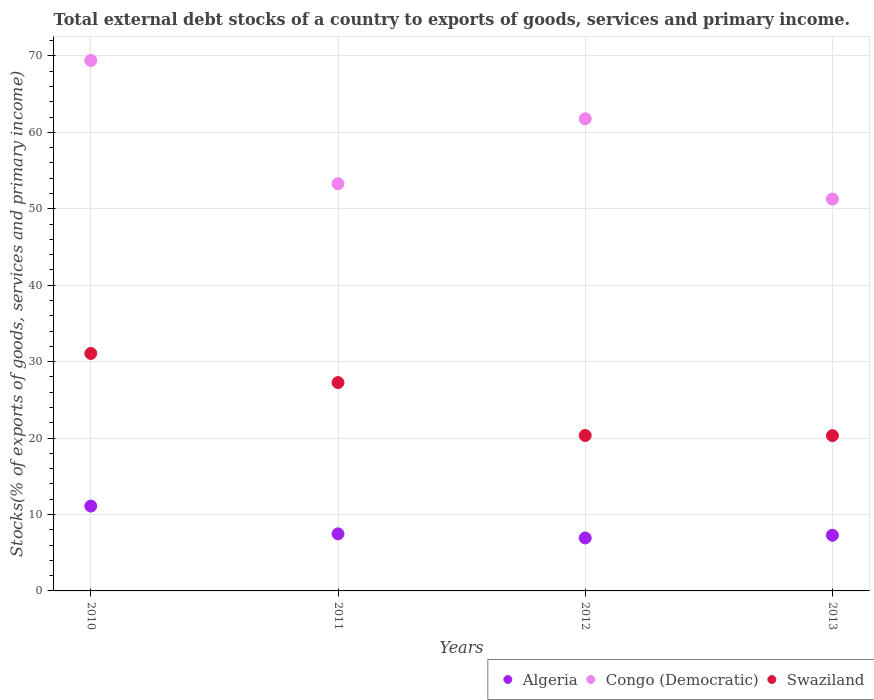How many different coloured dotlines are there?
Offer a very short reply. 3. What is the total debt stocks in Algeria in 2011?
Offer a terse response. 7.47. Across all years, what is the maximum total debt stocks in Swaziland?
Your answer should be very brief. 31.08. Across all years, what is the minimum total debt stocks in Algeria?
Your response must be concise. 6.93. In which year was the total debt stocks in Congo (Democratic) maximum?
Your answer should be very brief. 2010. In which year was the total debt stocks in Algeria minimum?
Give a very brief answer. 2012. What is the total total debt stocks in Algeria in the graph?
Give a very brief answer. 32.79. What is the difference between the total debt stocks in Congo (Democratic) in 2010 and that in 2012?
Your answer should be very brief. 7.63. What is the difference between the total debt stocks in Congo (Democratic) in 2011 and the total debt stocks in Algeria in 2013?
Your answer should be compact. 46. What is the average total debt stocks in Algeria per year?
Your answer should be very brief. 8.2. In the year 2013, what is the difference between the total debt stocks in Congo (Democratic) and total debt stocks in Swaziland?
Provide a succinct answer. 30.95. In how many years, is the total debt stocks in Congo (Democratic) greater than 62 %?
Keep it short and to the point. 1. What is the ratio of the total debt stocks in Swaziland in 2010 to that in 2011?
Give a very brief answer. 1.14. Is the total debt stocks in Swaziland in 2010 less than that in 2012?
Offer a very short reply. No. Is the difference between the total debt stocks in Congo (Democratic) in 2011 and 2012 greater than the difference between the total debt stocks in Swaziland in 2011 and 2012?
Offer a very short reply. No. What is the difference between the highest and the second highest total debt stocks in Algeria?
Your answer should be very brief. 3.64. What is the difference between the highest and the lowest total debt stocks in Congo (Democratic)?
Your answer should be very brief. 18.15. Is it the case that in every year, the sum of the total debt stocks in Swaziland and total debt stocks in Algeria  is greater than the total debt stocks in Congo (Democratic)?
Keep it short and to the point. No. Does the total debt stocks in Algeria monotonically increase over the years?
Your answer should be very brief. No. Is the total debt stocks in Algeria strictly greater than the total debt stocks in Swaziland over the years?
Offer a terse response. No. Is the total debt stocks in Congo (Democratic) strictly less than the total debt stocks in Swaziland over the years?
Offer a very short reply. No. How many dotlines are there?
Ensure brevity in your answer.  3. What is the difference between two consecutive major ticks on the Y-axis?
Provide a succinct answer. 10. Are the values on the major ticks of Y-axis written in scientific E-notation?
Your answer should be very brief. No. Does the graph contain any zero values?
Make the answer very short. No. Where does the legend appear in the graph?
Provide a succinct answer. Bottom right. What is the title of the graph?
Offer a terse response. Total external debt stocks of a country to exports of goods, services and primary income. What is the label or title of the X-axis?
Ensure brevity in your answer.  Years. What is the label or title of the Y-axis?
Keep it short and to the point. Stocks(% of exports of goods, services and primary income). What is the Stocks(% of exports of goods, services and primary income) of Algeria in 2010?
Ensure brevity in your answer.  11.1. What is the Stocks(% of exports of goods, services and primary income) in Congo (Democratic) in 2010?
Your answer should be very brief. 69.42. What is the Stocks(% of exports of goods, services and primary income) of Swaziland in 2010?
Provide a short and direct response. 31.08. What is the Stocks(% of exports of goods, services and primary income) of Algeria in 2011?
Ensure brevity in your answer.  7.47. What is the Stocks(% of exports of goods, services and primary income) of Congo (Democratic) in 2011?
Offer a terse response. 53.28. What is the Stocks(% of exports of goods, services and primary income) in Swaziland in 2011?
Give a very brief answer. 27.26. What is the Stocks(% of exports of goods, services and primary income) in Algeria in 2012?
Provide a succinct answer. 6.93. What is the Stocks(% of exports of goods, services and primary income) of Congo (Democratic) in 2012?
Provide a short and direct response. 61.78. What is the Stocks(% of exports of goods, services and primary income) in Swaziland in 2012?
Provide a succinct answer. 20.34. What is the Stocks(% of exports of goods, services and primary income) of Algeria in 2013?
Provide a succinct answer. 7.29. What is the Stocks(% of exports of goods, services and primary income) in Congo (Democratic) in 2013?
Your answer should be very brief. 51.27. What is the Stocks(% of exports of goods, services and primary income) of Swaziland in 2013?
Provide a succinct answer. 20.32. Across all years, what is the maximum Stocks(% of exports of goods, services and primary income) of Algeria?
Keep it short and to the point. 11.1. Across all years, what is the maximum Stocks(% of exports of goods, services and primary income) in Congo (Democratic)?
Provide a short and direct response. 69.42. Across all years, what is the maximum Stocks(% of exports of goods, services and primary income) of Swaziland?
Offer a terse response. 31.08. Across all years, what is the minimum Stocks(% of exports of goods, services and primary income) of Algeria?
Keep it short and to the point. 6.93. Across all years, what is the minimum Stocks(% of exports of goods, services and primary income) of Congo (Democratic)?
Your response must be concise. 51.27. Across all years, what is the minimum Stocks(% of exports of goods, services and primary income) in Swaziland?
Provide a short and direct response. 20.32. What is the total Stocks(% of exports of goods, services and primary income) in Algeria in the graph?
Give a very brief answer. 32.79. What is the total Stocks(% of exports of goods, services and primary income) of Congo (Democratic) in the graph?
Offer a terse response. 235.75. What is the total Stocks(% of exports of goods, services and primary income) in Swaziland in the graph?
Ensure brevity in your answer.  99.01. What is the difference between the Stocks(% of exports of goods, services and primary income) of Algeria in 2010 and that in 2011?
Your answer should be compact. 3.64. What is the difference between the Stocks(% of exports of goods, services and primary income) in Congo (Democratic) in 2010 and that in 2011?
Make the answer very short. 16.13. What is the difference between the Stocks(% of exports of goods, services and primary income) in Swaziland in 2010 and that in 2011?
Your answer should be very brief. 3.81. What is the difference between the Stocks(% of exports of goods, services and primary income) of Algeria in 2010 and that in 2012?
Offer a terse response. 4.17. What is the difference between the Stocks(% of exports of goods, services and primary income) of Congo (Democratic) in 2010 and that in 2012?
Ensure brevity in your answer.  7.63. What is the difference between the Stocks(% of exports of goods, services and primary income) of Swaziland in 2010 and that in 2012?
Your answer should be very brief. 10.73. What is the difference between the Stocks(% of exports of goods, services and primary income) in Algeria in 2010 and that in 2013?
Your answer should be very brief. 3.82. What is the difference between the Stocks(% of exports of goods, services and primary income) in Congo (Democratic) in 2010 and that in 2013?
Your answer should be compact. 18.15. What is the difference between the Stocks(% of exports of goods, services and primary income) in Swaziland in 2010 and that in 2013?
Your response must be concise. 10.76. What is the difference between the Stocks(% of exports of goods, services and primary income) in Algeria in 2011 and that in 2012?
Your answer should be compact. 0.54. What is the difference between the Stocks(% of exports of goods, services and primary income) in Congo (Democratic) in 2011 and that in 2012?
Provide a short and direct response. -8.5. What is the difference between the Stocks(% of exports of goods, services and primary income) in Swaziland in 2011 and that in 2012?
Your answer should be very brief. 6.92. What is the difference between the Stocks(% of exports of goods, services and primary income) in Algeria in 2011 and that in 2013?
Your response must be concise. 0.18. What is the difference between the Stocks(% of exports of goods, services and primary income) of Congo (Democratic) in 2011 and that in 2013?
Your answer should be very brief. 2.01. What is the difference between the Stocks(% of exports of goods, services and primary income) of Swaziland in 2011 and that in 2013?
Your response must be concise. 6.94. What is the difference between the Stocks(% of exports of goods, services and primary income) of Algeria in 2012 and that in 2013?
Your response must be concise. -0.36. What is the difference between the Stocks(% of exports of goods, services and primary income) of Congo (Democratic) in 2012 and that in 2013?
Ensure brevity in your answer.  10.51. What is the difference between the Stocks(% of exports of goods, services and primary income) in Swaziland in 2012 and that in 2013?
Your answer should be very brief. 0.02. What is the difference between the Stocks(% of exports of goods, services and primary income) of Algeria in 2010 and the Stocks(% of exports of goods, services and primary income) of Congo (Democratic) in 2011?
Provide a succinct answer. -42.18. What is the difference between the Stocks(% of exports of goods, services and primary income) of Algeria in 2010 and the Stocks(% of exports of goods, services and primary income) of Swaziland in 2011?
Your answer should be compact. -16.16. What is the difference between the Stocks(% of exports of goods, services and primary income) of Congo (Democratic) in 2010 and the Stocks(% of exports of goods, services and primary income) of Swaziland in 2011?
Provide a succinct answer. 42.15. What is the difference between the Stocks(% of exports of goods, services and primary income) in Algeria in 2010 and the Stocks(% of exports of goods, services and primary income) in Congo (Democratic) in 2012?
Ensure brevity in your answer.  -50.68. What is the difference between the Stocks(% of exports of goods, services and primary income) of Algeria in 2010 and the Stocks(% of exports of goods, services and primary income) of Swaziland in 2012?
Provide a succinct answer. -9.24. What is the difference between the Stocks(% of exports of goods, services and primary income) in Congo (Democratic) in 2010 and the Stocks(% of exports of goods, services and primary income) in Swaziland in 2012?
Ensure brevity in your answer.  49.07. What is the difference between the Stocks(% of exports of goods, services and primary income) of Algeria in 2010 and the Stocks(% of exports of goods, services and primary income) of Congo (Democratic) in 2013?
Provide a succinct answer. -40.17. What is the difference between the Stocks(% of exports of goods, services and primary income) of Algeria in 2010 and the Stocks(% of exports of goods, services and primary income) of Swaziland in 2013?
Give a very brief answer. -9.22. What is the difference between the Stocks(% of exports of goods, services and primary income) in Congo (Democratic) in 2010 and the Stocks(% of exports of goods, services and primary income) in Swaziland in 2013?
Keep it short and to the point. 49.1. What is the difference between the Stocks(% of exports of goods, services and primary income) in Algeria in 2011 and the Stocks(% of exports of goods, services and primary income) in Congo (Democratic) in 2012?
Give a very brief answer. -54.32. What is the difference between the Stocks(% of exports of goods, services and primary income) in Algeria in 2011 and the Stocks(% of exports of goods, services and primary income) in Swaziland in 2012?
Your answer should be compact. -12.88. What is the difference between the Stocks(% of exports of goods, services and primary income) in Congo (Democratic) in 2011 and the Stocks(% of exports of goods, services and primary income) in Swaziland in 2012?
Provide a succinct answer. 32.94. What is the difference between the Stocks(% of exports of goods, services and primary income) of Algeria in 2011 and the Stocks(% of exports of goods, services and primary income) of Congo (Democratic) in 2013?
Keep it short and to the point. -43.8. What is the difference between the Stocks(% of exports of goods, services and primary income) in Algeria in 2011 and the Stocks(% of exports of goods, services and primary income) in Swaziland in 2013?
Give a very brief answer. -12.85. What is the difference between the Stocks(% of exports of goods, services and primary income) in Congo (Democratic) in 2011 and the Stocks(% of exports of goods, services and primary income) in Swaziland in 2013?
Provide a short and direct response. 32.96. What is the difference between the Stocks(% of exports of goods, services and primary income) in Algeria in 2012 and the Stocks(% of exports of goods, services and primary income) in Congo (Democratic) in 2013?
Your answer should be very brief. -44.34. What is the difference between the Stocks(% of exports of goods, services and primary income) of Algeria in 2012 and the Stocks(% of exports of goods, services and primary income) of Swaziland in 2013?
Your response must be concise. -13.39. What is the difference between the Stocks(% of exports of goods, services and primary income) of Congo (Democratic) in 2012 and the Stocks(% of exports of goods, services and primary income) of Swaziland in 2013?
Your answer should be very brief. 41.46. What is the average Stocks(% of exports of goods, services and primary income) in Algeria per year?
Your response must be concise. 8.2. What is the average Stocks(% of exports of goods, services and primary income) of Congo (Democratic) per year?
Your answer should be very brief. 58.94. What is the average Stocks(% of exports of goods, services and primary income) of Swaziland per year?
Offer a terse response. 24.75. In the year 2010, what is the difference between the Stocks(% of exports of goods, services and primary income) of Algeria and Stocks(% of exports of goods, services and primary income) of Congo (Democratic)?
Offer a terse response. -58.31. In the year 2010, what is the difference between the Stocks(% of exports of goods, services and primary income) in Algeria and Stocks(% of exports of goods, services and primary income) in Swaziland?
Offer a terse response. -19.97. In the year 2010, what is the difference between the Stocks(% of exports of goods, services and primary income) in Congo (Democratic) and Stocks(% of exports of goods, services and primary income) in Swaziland?
Give a very brief answer. 38.34. In the year 2011, what is the difference between the Stocks(% of exports of goods, services and primary income) in Algeria and Stocks(% of exports of goods, services and primary income) in Congo (Democratic)?
Provide a short and direct response. -45.82. In the year 2011, what is the difference between the Stocks(% of exports of goods, services and primary income) in Algeria and Stocks(% of exports of goods, services and primary income) in Swaziland?
Provide a short and direct response. -19.8. In the year 2011, what is the difference between the Stocks(% of exports of goods, services and primary income) in Congo (Democratic) and Stocks(% of exports of goods, services and primary income) in Swaziland?
Keep it short and to the point. 26.02. In the year 2012, what is the difference between the Stocks(% of exports of goods, services and primary income) in Algeria and Stocks(% of exports of goods, services and primary income) in Congo (Democratic)?
Your answer should be very brief. -54.85. In the year 2012, what is the difference between the Stocks(% of exports of goods, services and primary income) of Algeria and Stocks(% of exports of goods, services and primary income) of Swaziland?
Your answer should be very brief. -13.41. In the year 2012, what is the difference between the Stocks(% of exports of goods, services and primary income) in Congo (Democratic) and Stocks(% of exports of goods, services and primary income) in Swaziland?
Keep it short and to the point. 41.44. In the year 2013, what is the difference between the Stocks(% of exports of goods, services and primary income) of Algeria and Stocks(% of exports of goods, services and primary income) of Congo (Democratic)?
Your response must be concise. -43.98. In the year 2013, what is the difference between the Stocks(% of exports of goods, services and primary income) in Algeria and Stocks(% of exports of goods, services and primary income) in Swaziland?
Keep it short and to the point. -13.03. In the year 2013, what is the difference between the Stocks(% of exports of goods, services and primary income) in Congo (Democratic) and Stocks(% of exports of goods, services and primary income) in Swaziland?
Keep it short and to the point. 30.95. What is the ratio of the Stocks(% of exports of goods, services and primary income) of Algeria in 2010 to that in 2011?
Keep it short and to the point. 1.49. What is the ratio of the Stocks(% of exports of goods, services and primary income) in Congo (Democratic) in 2010 to that in 2011?
Provide a short and direct response. 1.3. What is the ratio of the Stocks(% of exports of goods, services and primary income) in Swaziland in 2010 to that in 2011?
Give a very brief answer. 1.14. What is the ratio of the Stocks(% of exports of goods, services and primary income) of Algeria in 2010 to that in 2012?
Your answer should be compact. 1.6. What is the ratio of the Stocks(% of exports of goods, services and primary income) of Congo (Democratic) in 2010 to that in 2012?
Your response must be concise. 1.12. What is the ratio of the Stocks(% of exports of goods, services and primary income) of Swaziland in 2010 to that in 2012?
Provide a succinct answer. 1.53. What is the ratio of the Stocks(% of exports of goods, services and primary income) in Algeria in 2010 to that in 2013?
Keep it short and to the point. 1.52. What is the ratio of the Stocks(% of exports of goods, services and primary income) in Congo (Democratic) in 2010 to that in 2013?
Keep it short and to the point. 1.35. What is the ratio of the Stocks(% of exports of goods, services and primary income) of Swaziland in 2010 to that in 2013?
Make the answer very short. 1.53. What is the ratio of the Stocks(% of exports of goods, services and primary income) of Algeria in 2011 to that in 2012?
Ensure brevity in your answer.  1.08. What is the ratio of the Stocks(% of exports of goods, services and primary income) in Congo (Democratic) in 2011 to that in 2012?
Keep it short and to the point. 0.86. What is the ratio of the Stocks(% of exports of goods, services and primary income) of Swaziland in 2011 to that in 2012?
Ensure brevity in your answer.  1.34. What is the ratio of the Stocks(% of exports of goods, services and primary income) in Algeria in 2011 to that in 2013?
Make the answer very short. 1.02. What is the ratio of the Stocks(% of exports of goods, services and primary income) of Congo (Democratic) in 2011 to that in 2013?
Provide a succinct answer. 1.04. What is the ratio of the Stocks(% of exports of goods, services and primary income) in Swaziland in 2011 to that in 2013?
Provide a succinct answer. 1.34. What is the ratio of the Stocks(% of exports of goods, services and primary income) in Algeria in 2012 to that in 2013?
Your response must be concise. 0.95. What is the ratio of the Stocks(% of exports of goods, services and primary income) of Congo (Democratic) in 2012 to that in 2013?
Ensure brevity in your answer.  1.21. What is the difference between the highest and the second highest Stocks(% of exports of goods, services and primary income) of Algeria?
Provide a succinct answer. 3.64. What is the difference between the highest and the second highest Stocks(% of exports of goods, services and primary income) in Congo (Democratic)?
Make the answer very short. 7.63. What is the difference between the highest and the second highest Stocks(% of exports of goods, services and primary income) of Swaziland?
Give a very brief answer. 3.81. What is the difference between the highest and the lowest Stocks(% of exports of goods, services and primary income) of Algeria?
Make the answer very short. 4.17. What is the difference between the highest and the lowest Stocks(% of exports of goods, services and primary income) in Congo (Democratic)?
Make the answer very short. 18.15. What is the difference between the highest and the lowest Stocks(% of exports of goods, services and primary income) in Swaziland?
Your answer should be compact. 10.76. 